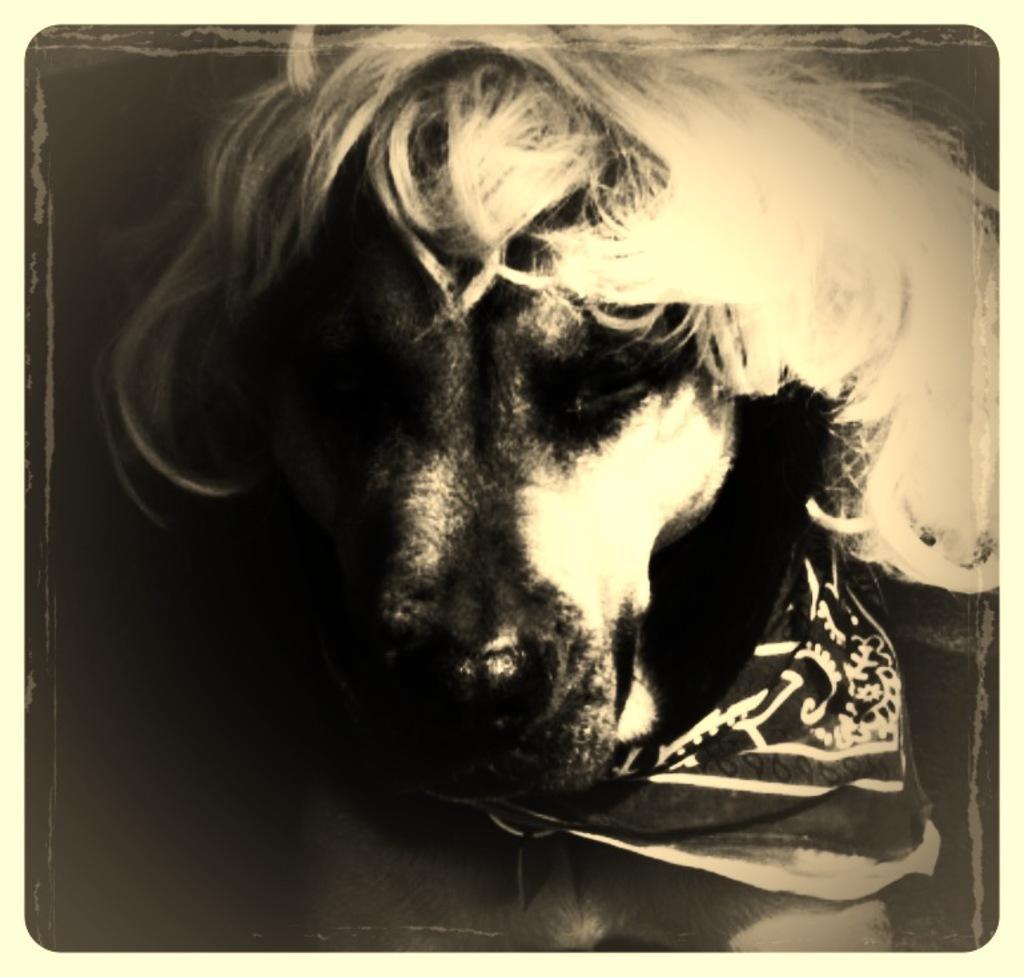Can you describe this image briefly? In this picture I can see the dog. On his neck I can see the cloth. On the left I can see the darkness. 